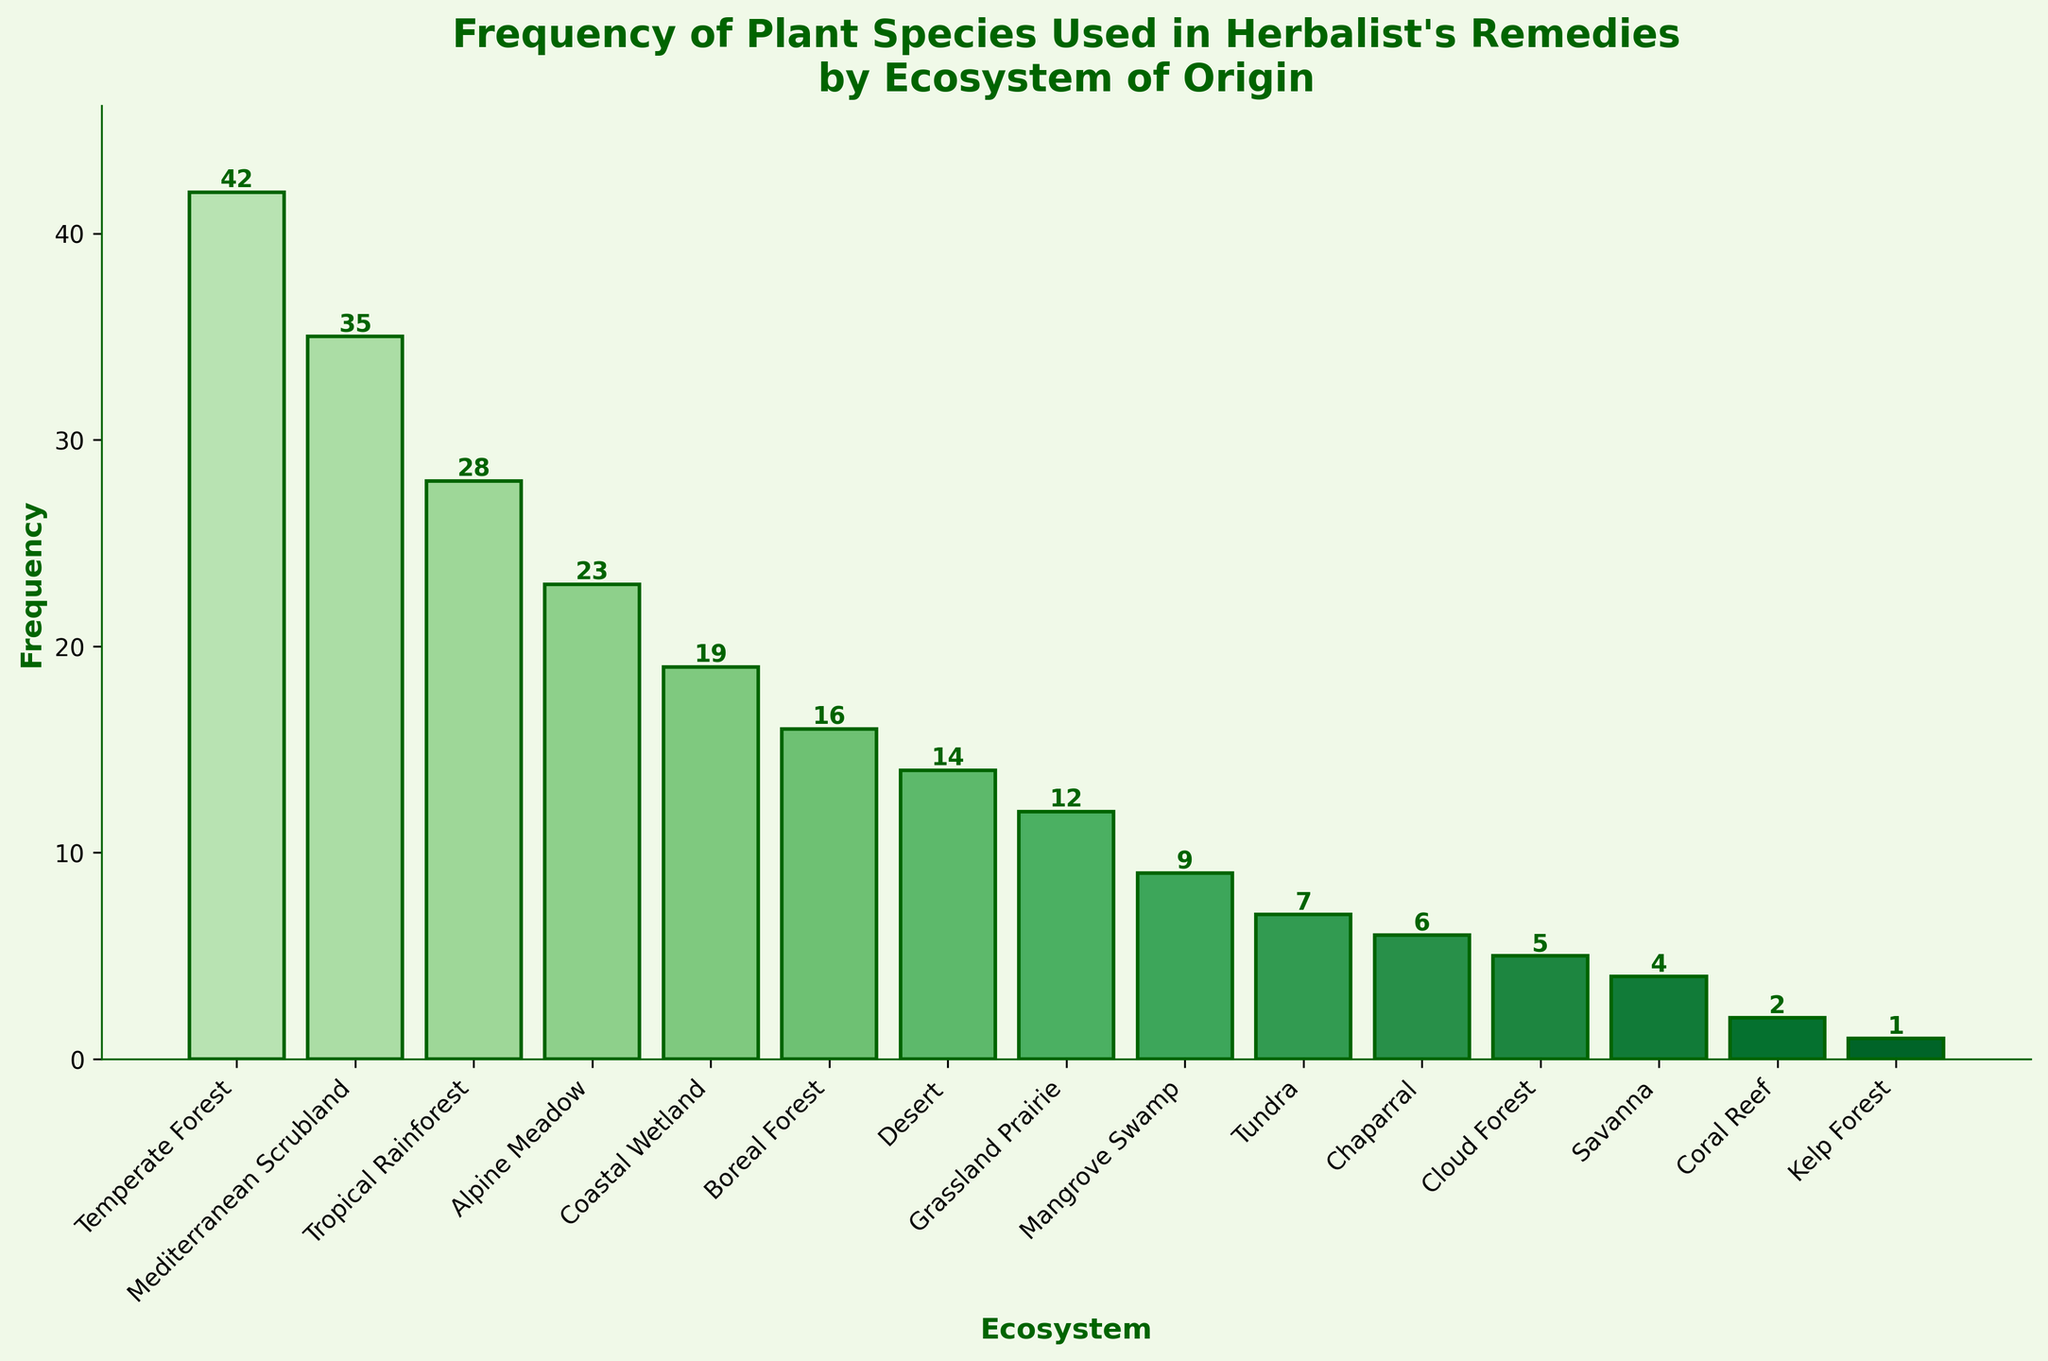what is the average frequency of plant species across all ecosystems? To find the average frequency, sum up all the frequencies and divide by the number of ecosystems. The total frequency is 42 + 35 + 28 + 23 + 19 + 16 + 14 + 12 + 9 + 7 + 6 + 5 + 4 + 2 + 1 = 223. There are 15 ecosystems. The average frequency is 223 / 15 = 14.87
Answer: 14.87 Which ecosystem has the highest frequency of used plant species? By looking at the heights of the bars, the ecosystem with the highest bar is the Temperate Forest with a frequency of 42.
Answer: Temperate Forest How much more frequent are plants from the Temperate Forest than from the Boreal Forest? To determine this, subtract the frequency of Boreal Forest from the frequency of Temperate Forest. 42 - 16 = 26
Answer: 26 Are there more plant species used from the Coastal Wetland or from the Grassland Prairie? By comparing the heights of the bars, Coastal Wetland has a frequency of 19, and Grassland Prairie has 12. Coastal Wetland has more.
Answer: Coastal Wetland What is the total frequency of plant species used from the ecosystems with a frequency of over 20? The relevant frequencies are Temperate Forest (42), Mediterranean Scrubland (35), Tropical Rainforest (28), and Alpine Meadow (23). Summing these gives 42 + 35 + 28 + 23 = 128
Answer: 128 Which ecosystems have plant species usage frequencies that are less than 10? Looking at the heights of the bars, the ecosystems with frequencies less than 10 are Mangrove Swamp (9), Tundra (7), Chaparral (6), Cloud Forest (5), Savanna (4), Coral Reef (2), and Kelp Forest (1).
Answer: Mangrove Swamp, Tundra, Chaparral, Cloud Forest, Savanna, Coral Reef, Kelp Forest What is the difference in frequency between the ecosystem with the highest frequency and the one with the lowest frequency? The highest frequency is Temperate Forest with 42, and the lowest is Kelp Forest with 1. The difference is 42 - 1 = 41
Answer: 41 What is the combined frequency of plant species from Desert and Grassland Prairie ecosystems? To find the combined frequency, add the frequencies of the Desert (14) and Grassland Prairie (12). 14 + 12 = 26
Answer: 26 Which ecosystem has the second-highest frequency of used plant species? The ecosystem with the second-highest bar is Mediterranean Scrubland with a frequency of 35.
Answer: Mediterranean Scrubland What fraction of the total number of frequencies does the Tropical Rainforest represent? First, find the total frequency: 223. Then, calculate the fraction for Tropical Rainforest, which has a frequency of 28. The fraction is 28/223 ≈ 0.1257
Answer: 0.1257 